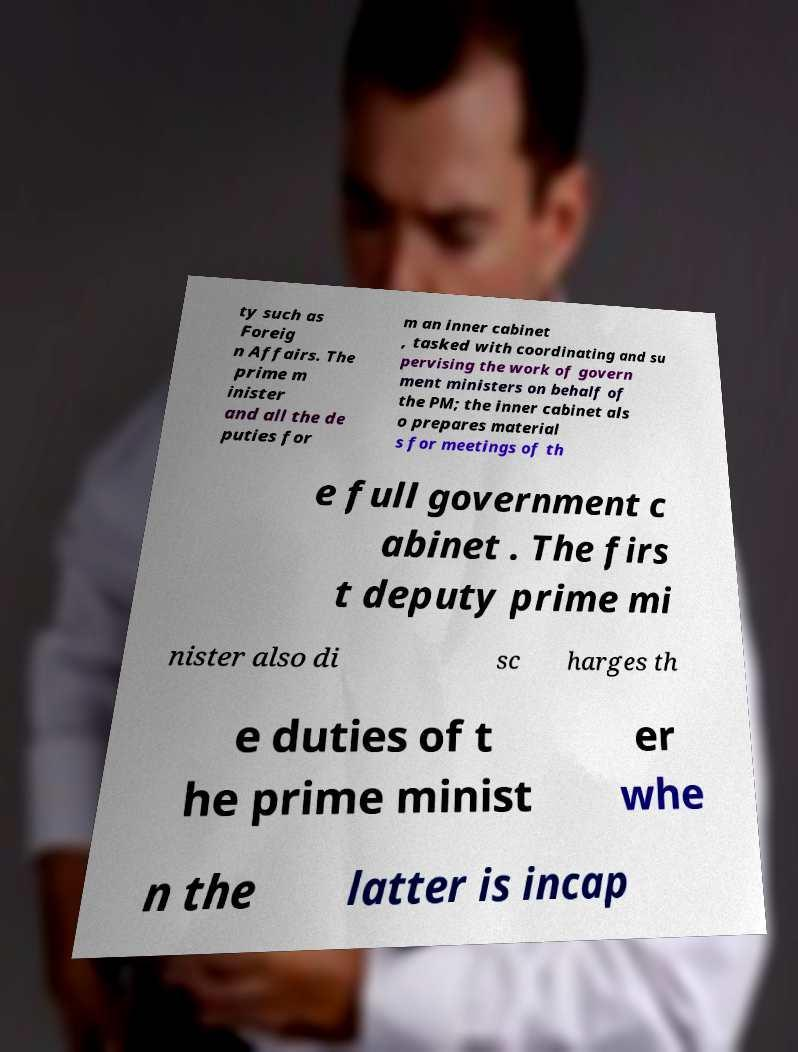Could you extract and type out the text from this image? ty such as Foreig n Affairs. The prime m inister and all the de puties for m an inner cabinet , tasked with coordinating and su pervising the work of govern ment ministers on behalf of the PM; the inner cabinet als o prepares material s for meetings of th e full government c abinet . The firs t deputy prime mi nister also di sc harges th e duties of t he prime minist er whe n the latter is incap 